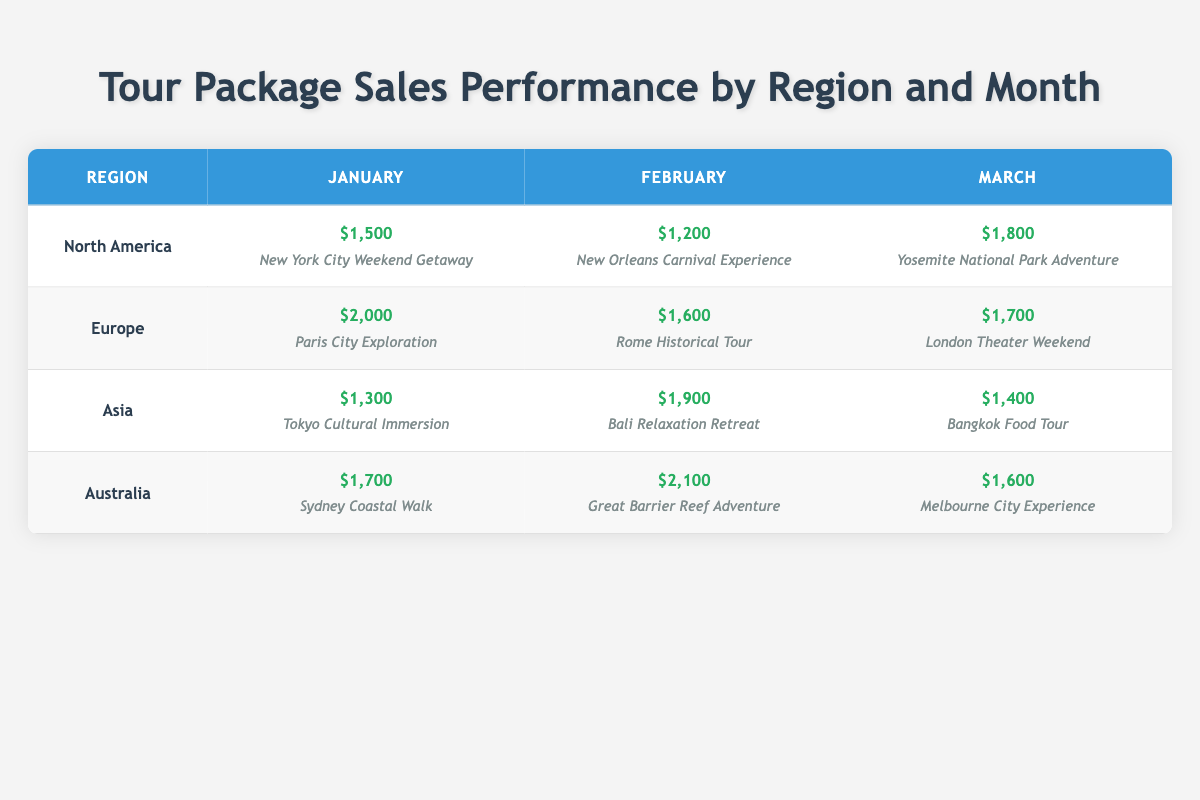What was the highest sales amount in January? In January, the sales amounts for each region are as follows: North America - $1,500, Europe - $2,000, Asia - $1,300, Australia - $1,700. The highest among these is $2,000 from Europe.
Answer: $2,000 Which tour package had the highest sales in February? In February, the sales amounts for each region are: North America - $1,200 (New Orleans Carnival Experience), Europe - $1,600 (Rome Historical Tour), Asia - $1,900 (Bali Relaxation Retreat), Australia - $2,100 (Great Barrier Reef Adventure). The highest is $2,100 for the Great Barrier Reef Adventure package.
Answer: Great Barrier Reef Adventure What is the total sales amount for Asia across all months? The sales amounts for Asia are: January - $1,300, February - $1,900, March - $1,400. To find the total, we add these values: $1,300 + $1,900 + $1,400 = $4,600.
Answer: $4,600 Did Australia have a better performance in March compared to North America? In March, the sales for Australia are $1,600 (Melbourne City Experience) and for North America are $1,800 (Yosemite National Park Adventure). Since $1,600 is less than $1,800, Australia did not perform better in March.
Answer: No What is the average sales amount for North America over the three months? The sales for North America over the three months are: January - $1,500, February - $1,200, March - $1,800. To find the average, we sum these values: $1,500 + $1,200 + $1,800 = $4,500, then divide by 3: $4,500 / 3 = $1,500.
Answer: $1,500 Which region had the smallest total sales for the first quarter? The total sales for each region in the first quarter are: North America - $4,500, Europe - $5,300, Asia - $4,600, Australia - $4,400. The smallest total sales amount is $4,400 for Australia.
Answer: Australia Was the sales for the Tokyo Cultural Immersion package higher than the sales for the New York City Weekend Getaway? The sales amount for the Tokyo Cultural Immersion package is $1,300, while the sales for the New York City Weekend Getaway is $1,500. Since $1,300 is less than $1,500, it was not higher.
Answer: No What is the highest sales amount for Europe in the entire quarter? The sales amounts for Europe are: January - $2,000, February - $1,600, March - $1,700. The highest sales amount in Europe is $2,000 recorded in January.
Answer: $2,000 